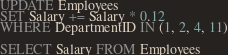Convert code to text. <code><loc_0><loc_0><loc_500><loc_500><_SQL_>UPDATE Employees
SET Salary += Salary * 0.12
WHERE DepartmentID IN (1, 2, 4, 11)

SELECT Salary FROM Employees</code> 